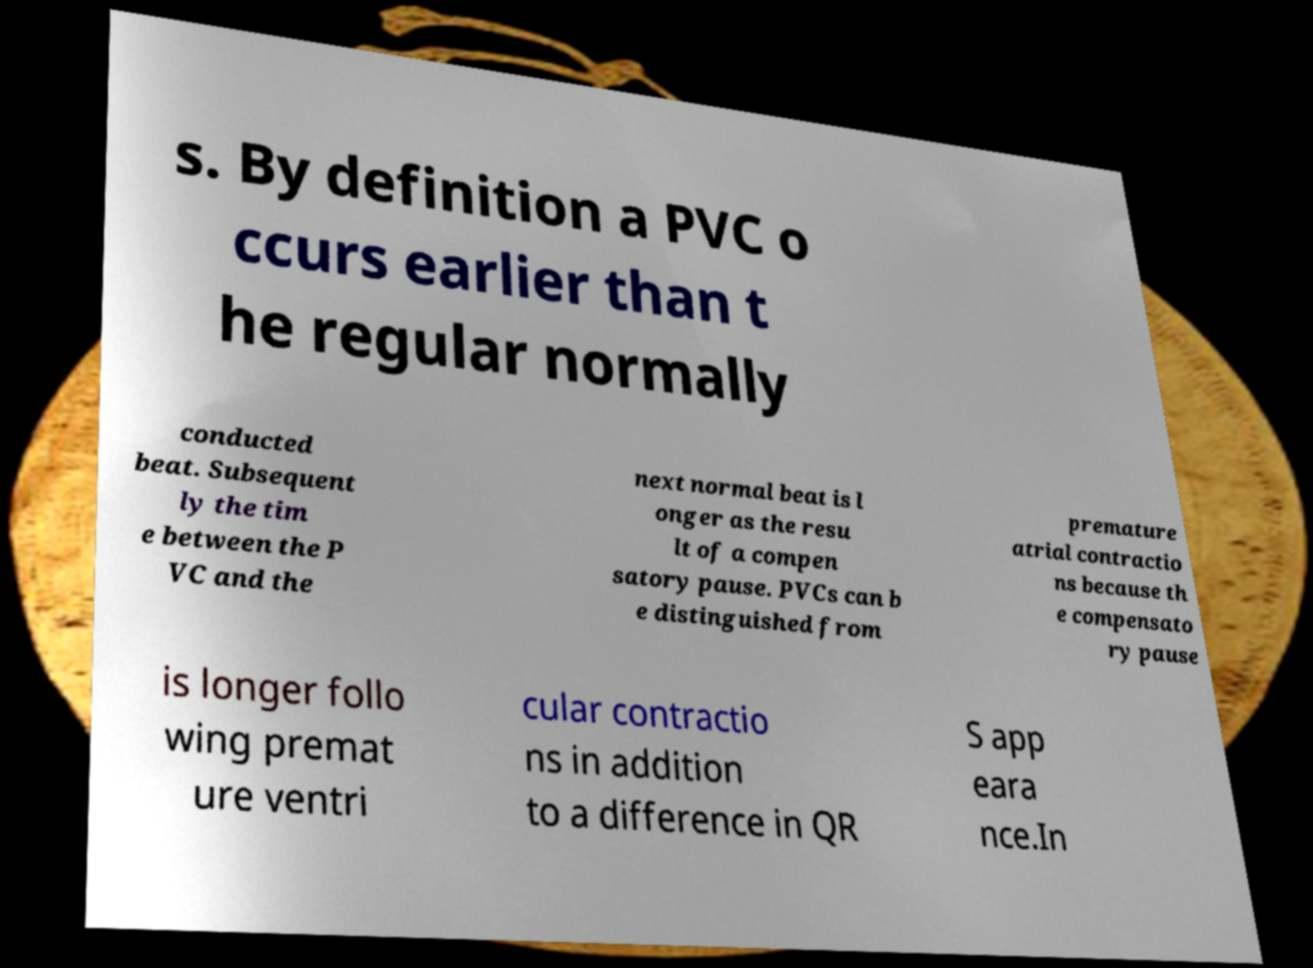Please identify and transcribe the text found in this image. s. By definition a PVC o ccurs earlier than t he regular normally conducted beat. Subsequent ly the tim e between the P VC and the next normal beat is l onger as the resu lt of a compen satory pause. PVCs can b e distinguished from premature atrial contractio ns because th e compensato ry pause is longer follo wing premat ure ventri cular contractio ns in addition to a difference in QR S app eara nce.In 